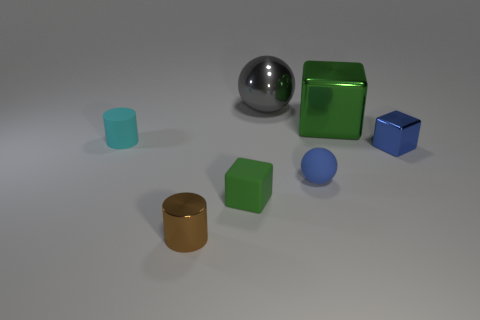There is a tiny thing that is the same color as the small rubber sphere; what shape is it?
Keep it short and to the point. Cube. How many rubber balls have the same size as the cyan object?
Ensure brevity in your answer.  1. How many things are spheres right of the big ball or shiny objects in front of the small cyan rubber object?
Make the answer very short. 3. Are the small cylinder that is in front of the matte cylinder and the large block that is on the right side of the green rubber object made of the same material?
Your answer should be very brief. Yes. The small shiny thing that is in front of the metallic thing right of the large metal cube is what shape?
Your answer should be very brief. Cylinder. Is there anything else that is the same color as the big cube?
Provide a succinct answer. Yes. There is a small metal thing in front of the small shiny object that is to the right of the brown cylinder; is there a large gray metal sphere that is on the left side of it?
Give a very brief answer. No. Does the ball that is on the left side of the blue ball have the same color as the rubber object that is on the left side of the brown metallic thing?
Ensure brevity in your answer.  No. What is the material of the other thing that is the same size as the gray object?
Ensure brevity in your answer.  Metal. What is the size of the green object behind the tiny metallic object right of the green object that is behind the green matte object?
Provide a succinct answer. Large. 